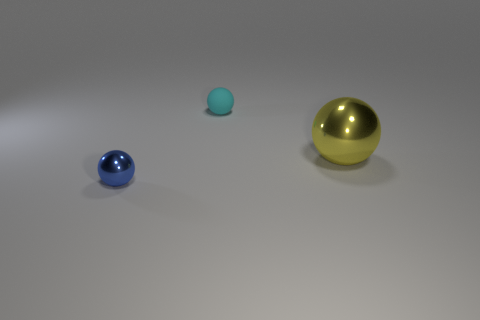Is there anything else that is the same material as the cyan ball?
Make the answer very short. No. Do the yellow shiny sphere and the object that is on the left side of the tiny cyan rubber thing have the same size?
Provide a short and direct response. No. What number of objects are either large yellow metallic things or objects in front of the cyan matte thing?
Your answer should be compact. 2. There is a metal ball that is to the left of the big yellow metallic object; is its size the same as the thing that is behind the yellow object?
Offer a terse response. Yes. Is there a large yellow ball that has the same material as the blue ball?
Your answer should be very brief. Yes. There is a big yellow metal thing; what shape is it?
Provide a short and direct response. Sphere. How many other objects are the same shape as the yellow thing?
Your answer should be compact. 2. What is the size of the metal sphere that is behind the tiny thing in front of the tiny cyan sphere?
Your response must be concise. Large. Is there a purple shiny object?
Provide a short and direct response. No. There is a metal object that is on the right side of the tiny rubber thing; how many blue balls are left of it?
Your answer should be compact. 1. 